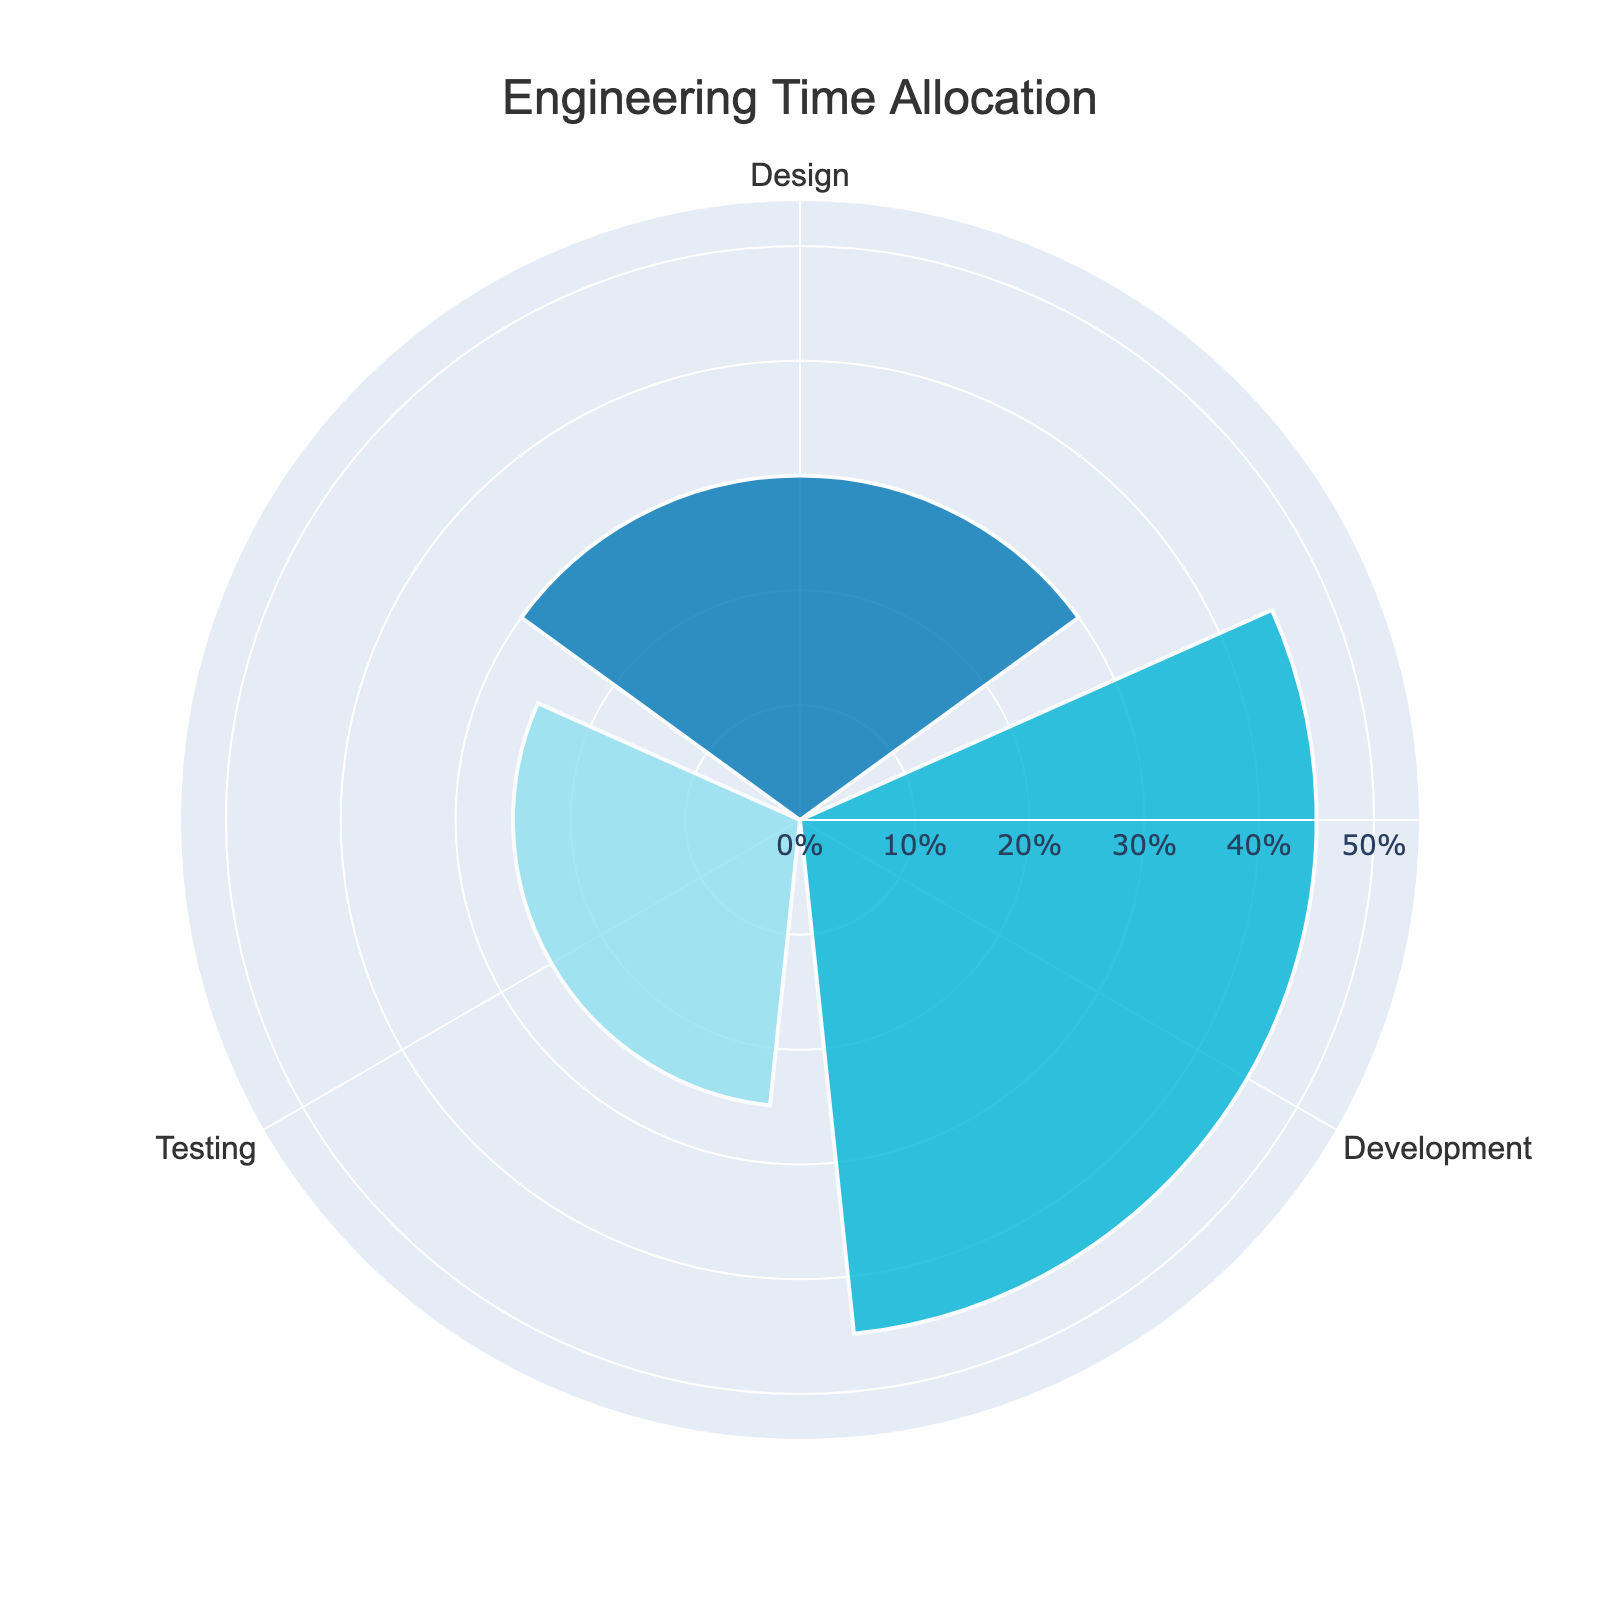What is the title of the figure? The title of the figure is prominently displayed at the top center of the chart. It reads "Engineering Time Allocation".
Answer: Engineering Time Allocation What are the percentages for each activity? The chart shows three activities each with a specific percentage: Design (30%), Development (45%), and Testing (25%). These values are marked along the radial axis.
Answer: Design: 30%, Development: 45%, Testing: 25% Which activity has the highest percentage? By observing the lengths of the bars on the rose chart, Development has the highest percentage. It extends the farthest from the center.
Answer: Development How much more time is spent on Development compared to Design? Development has a percentage of 45% and Design has 30%. The difference in time allocation is calculated by subtracting 30% from 45%.
Answer: 15% What is the combined percentage for Design and Testing? The percentage for Design is 30% and for Testing is 25%. Adding these together yields a combined percentage of 55%.
Answer: 55% What is the average time allocation across all activities? To find the average, add the percentages of all three activities: Design (30%) + Development (45%) + Testing (25%) equals 100%. Dividing 100% by 3 activities gives approximately 33.33%.
Answer: 33.33% How is the radial axis customized in the figure? The radial axis is marked with visible ticks and a range up to 54%, which is 1.2 times the highest value (45%). These ticks suffix with '%' and show readable fonts.
Answer: Ticks visible, range up to 54% If the time allocation for Testing was increased by 10%, what would the new percentage be? The current allocation for Testing is 25%. Adding 10% to this means the new percentage would be 25% + 10% = 35%.
Answer: 35% What color represents the Testing activity in the chart? The Testing activity is represented by a light blue shade, distinguishable from the other colors used for Design and Development, which are darker blue shades.
Answer: Light blue Is the distribution of time more or less uniform across activities? By examining the chart, there is a significant difference in time allocation, with Development taking up the most and Testing the least, indicating a non-uniform distribution.
Answer: Less uniform 